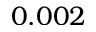<formula> <loc_0><loc_0><loc_500><loc_500>0 . 0 0 2</formula> 